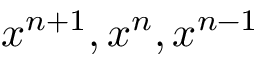Convert formula to latex. <formula><loc_0><loc_0><loc_500><loc_500>x ^ { n + 1 } , x ^ { n } , x ^ { n - 1 }</formula> 